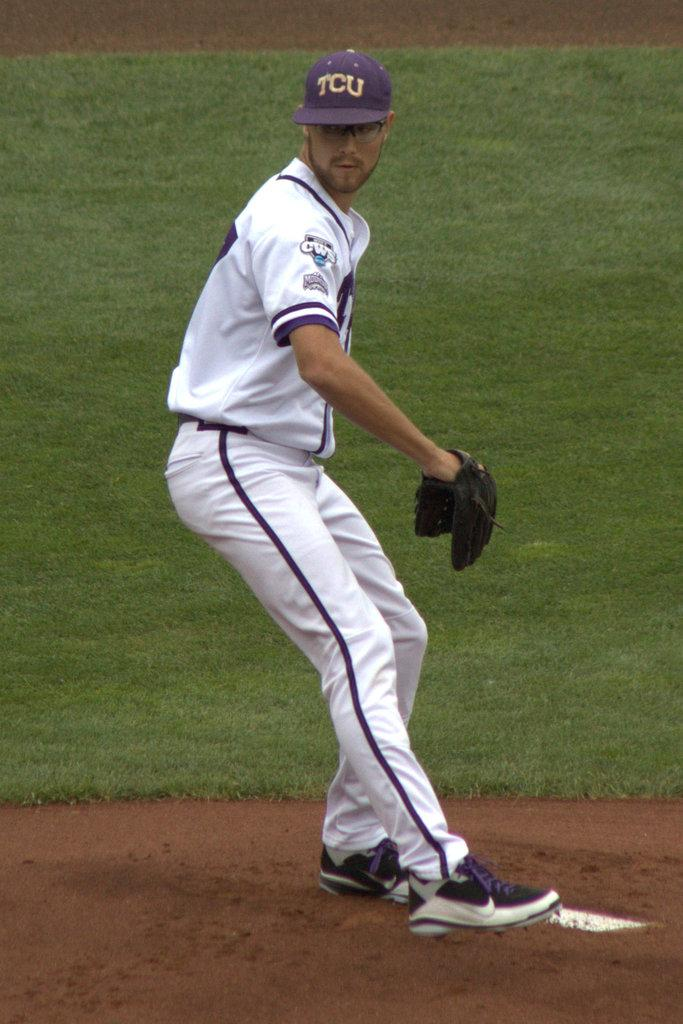Provide a one-sentence caption for the provided image. A baseball player wearing a cap written TCU on it. 